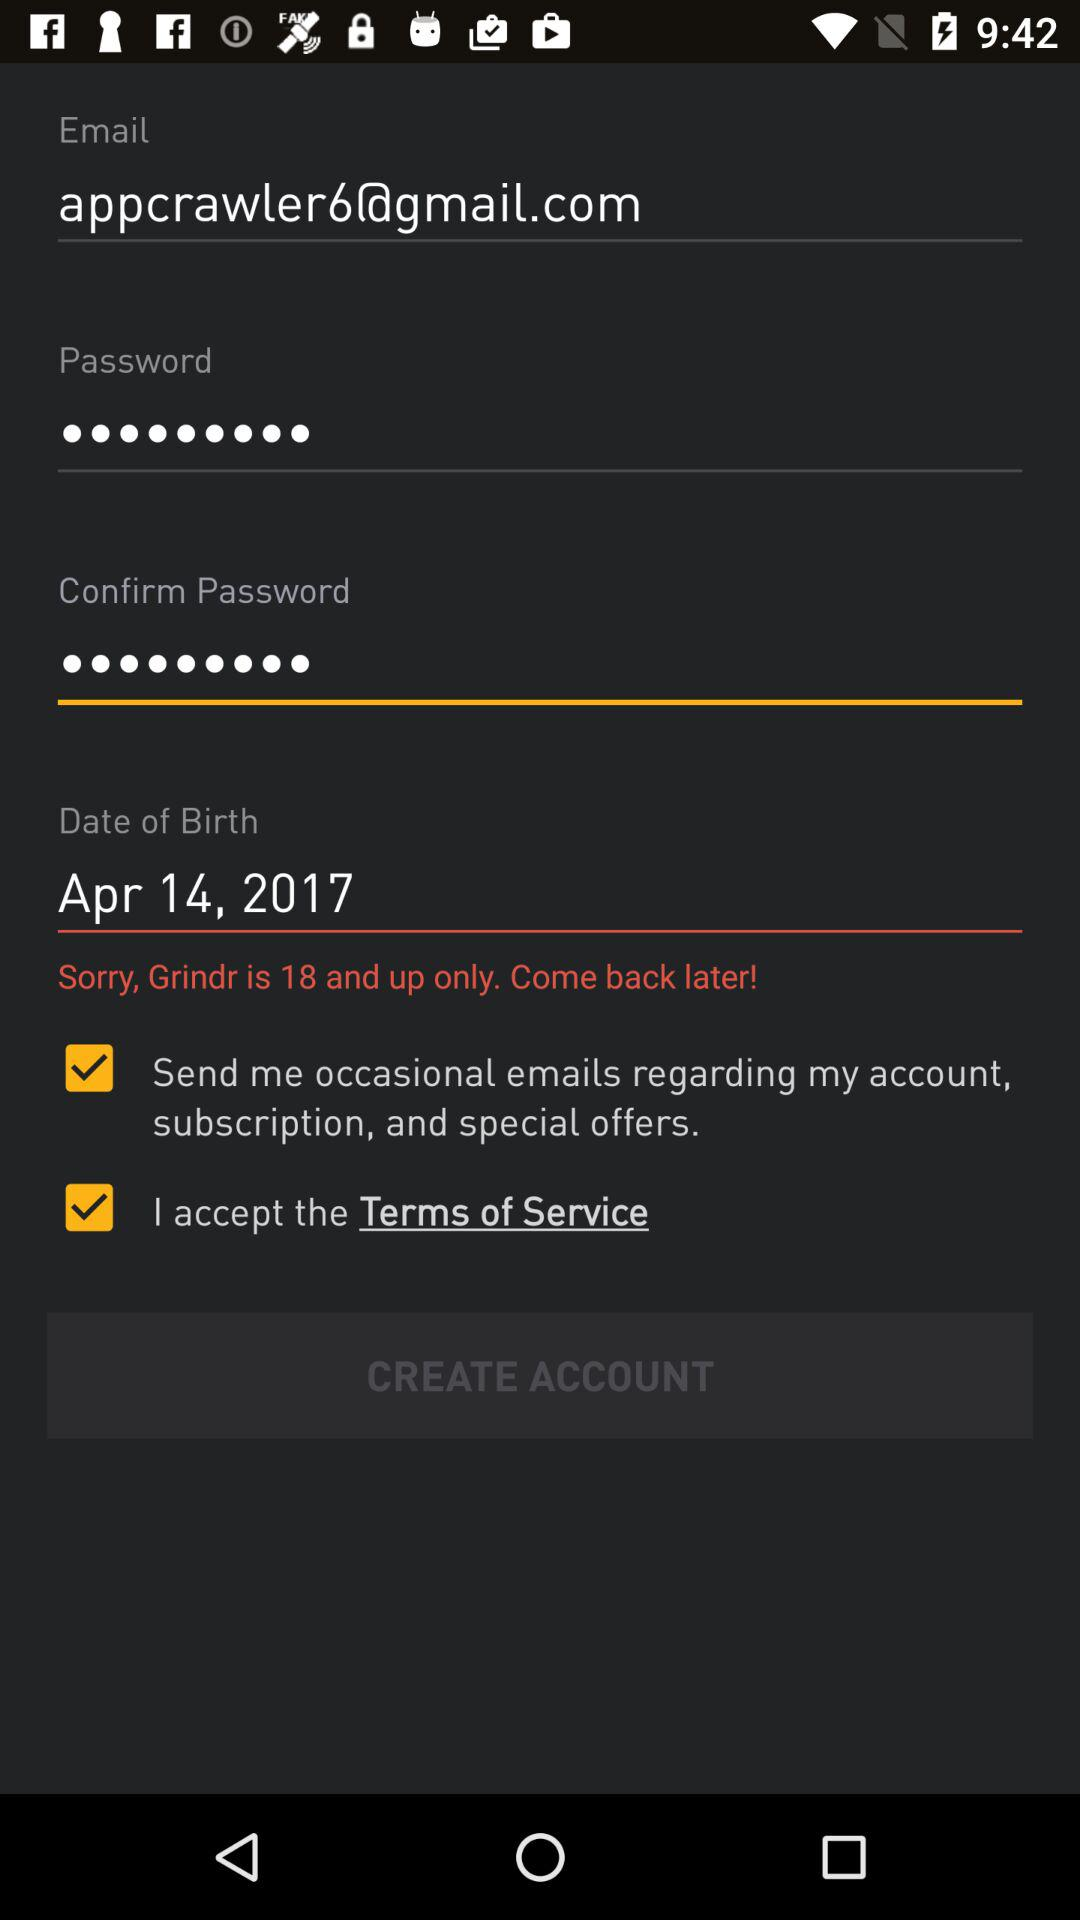What is the name of the application? The name of the application is "Grindr". 